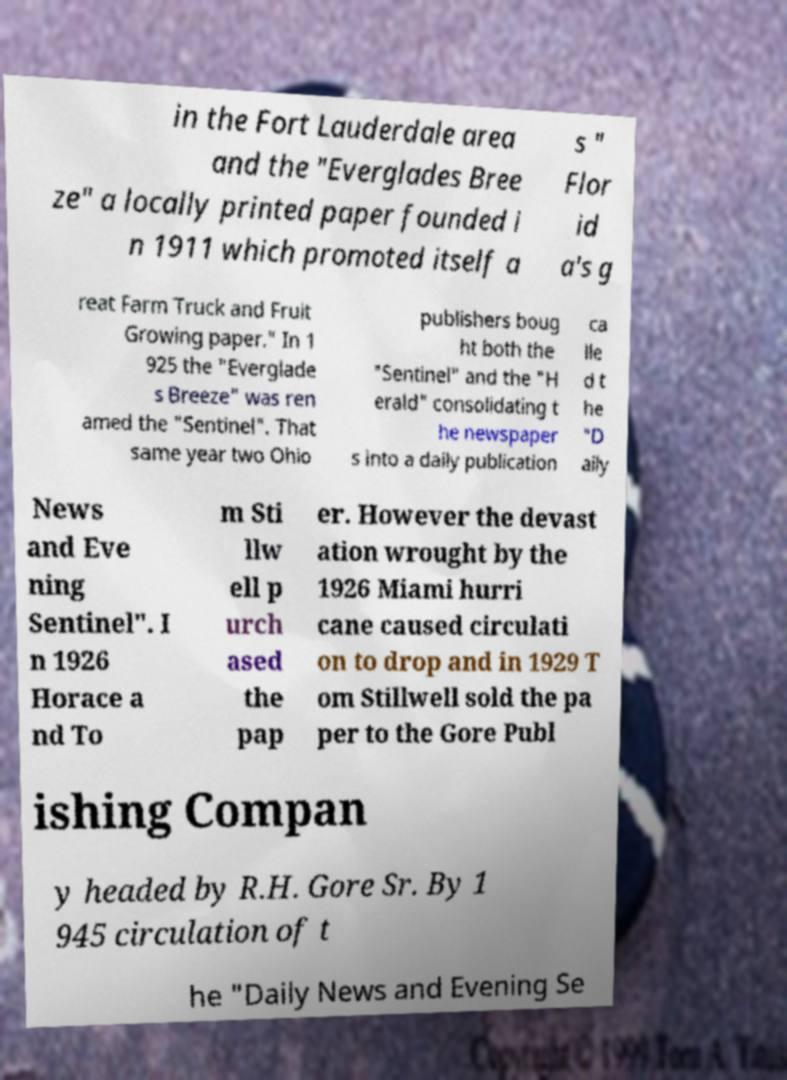Please identify and transcribe the text found in this image. in the Fort Lauderdale area and the "Everglades Bree ze" a locally printed paper founded i n 1911 which promoted itself a s " Flor id a's g reat Farm Truck and Fruit Growing paper." In 1 925 the "Everglade s Breeze" was ren amed the "Sentinel". That same year two Ohio publishers boug ht both the "Sentinel" and the "H erald" consolidating t he newspaper s into a daily publication ca lle d t he "D aily News and Eve ning Sentinel". I n 1926 Horace a nd To m Sti llw ell p urch ased the pap er. However the devast ation wrought by the 1926 Miami hurri cane caused circulati on to drop and in 1929 T om Stillwell sold the pa per to the Gore Publ ishing Compan y headed by R.H. Gore Sr. By 1 945 circulation of t he "Daily News and Evening Se 